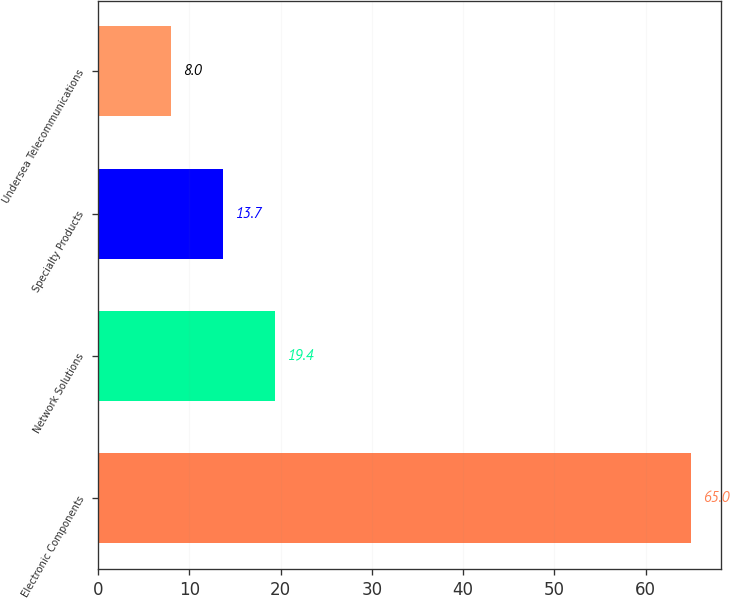Convert chart. <chart><loc_0><loc_0><loc_500><loc_500><bar_chart><fcel>Electronic Components<fcel>Network Solutions<fcel>Specialty Products<fcel>Undersea Telecommunications<nl><fcel>65<fcel>19.4<fcel>13.7<fcel>8<nl></chart> 